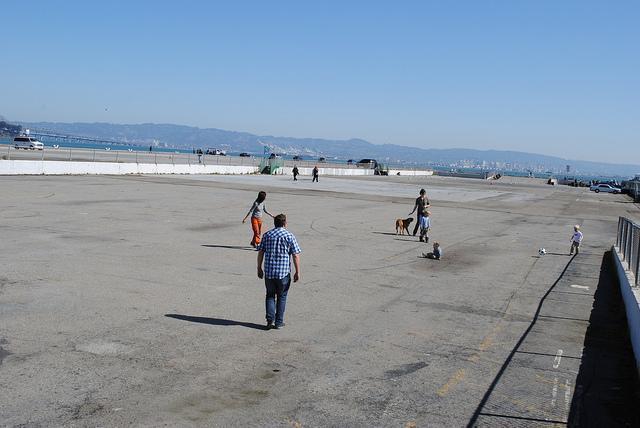What venue is it likely to be?
Make your selection from the four choices given to correctly answer the question.
Options: Football field, airfield, zoo, park. Airfield. 